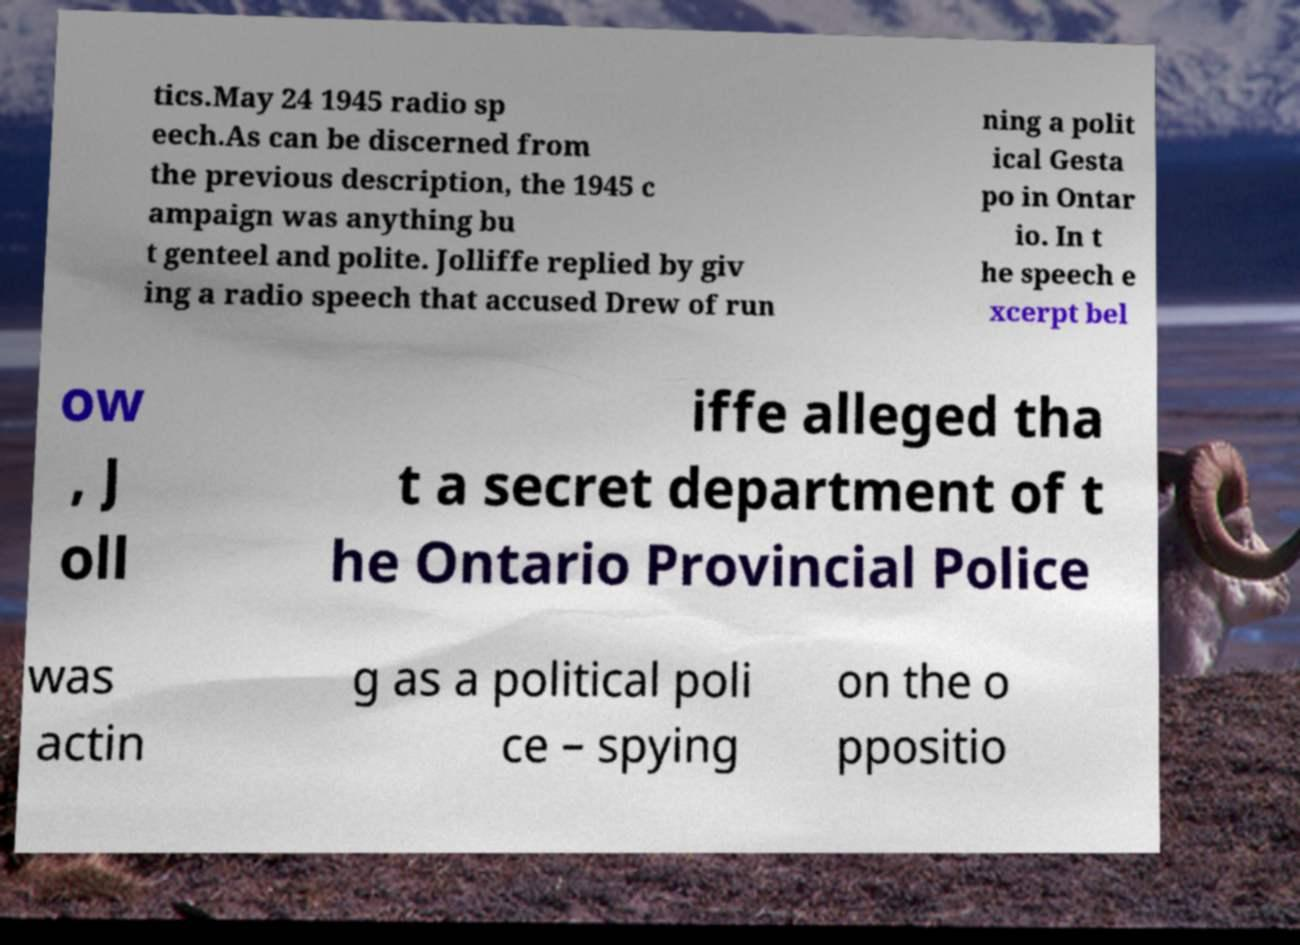What messages or text are displayed in this image? I need them in a readable, typed format. tics.May 24 1945 radio sp eech.As can be discerned from the previous description, the 1945 c ampaign was anything bu t genteel and polite. Jolliffe replied by giv ing a radio speech that accused Drew of run ning a polit ical Gesta po in Ontar io. In t he speech e xcerpt bel ow , J oll iffe alleged tha t a secret department of t he Ontario Provincial Police was actin g as a political poli ce – spying on the o ppositio 